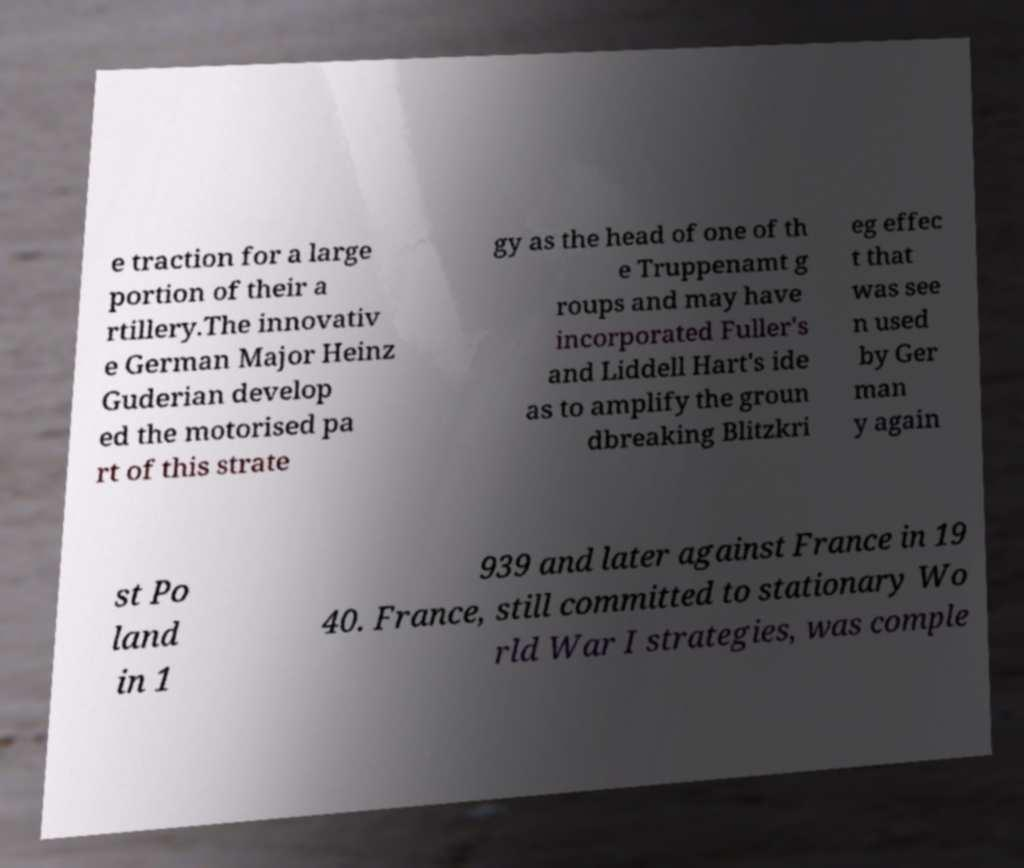Could you extract and type out the text from this image? e traction for a large portion of their a rtillery.The innovativ e German Major Heinz Guderian develop ed the motorised pa rt of this strate gy as the head of one of th e Truppenamt g roups and may have incorporated Fuller's and Liddell Hart's ide as to amplify the groun dbreaking Blitzkri eg effec t that was see n used by Ger man y again st Po land in 1 939 and later against France in 19 40. France, still committed to stationary Wo rld War I strategies, was comple 